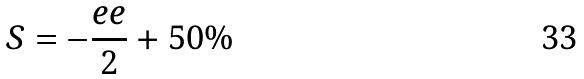<formula> <loc_0><loc_0><loc_500><loc_500>S = - \frac { e e } { 2 } + 5 0 \%</formula> 